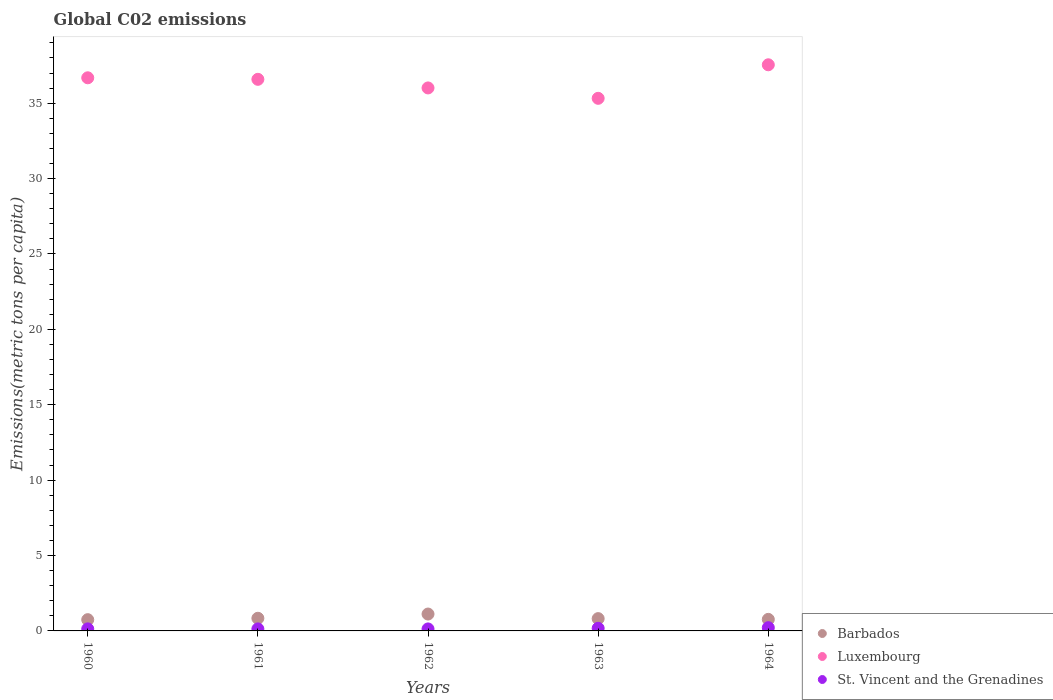Is the number of dotlines equal to the number of legend labels?
Offer a very short reply. Yes. What is the amount of CO2 emitted in in St. Vincent and the Grenadines in 1962?
Provide a succinct answer. 0.13. Across all years, what is the maximum amount of CO2 emitted in in St. Vincent and the Grenadines?
Provide a short and direct response. 0.22. Across all years, what is the minimum amount of CO2 emitted in in Barbados?
Offer a terse response. 0.75. In which year was the amount of CO2 emitted in in Barbados minimum?
Your answer should be compact. 1960. What is the total amount of CO2 emitted in in Luxembourg in the graph?
Your answer should be very brief. 182.15. What is the difference between the amount of CO2 emitted in in Barbados in 1960 and that in 1964?
Your response must be concise. -0.02. What is the difference between the amount of CO2 emitted in in Luxembourg in 1960 and the amount of CO2 emitted in in St. Vincent and the Grenadines in 1961?
Ensure brevity in your answer.  36.55. What is the average amount of CO2 emitted in in Luxembourg per year?
Your response must be concise. 36.43. In the year 1963, what is the difference between the amount of CO2 emitted in in Barbados and amount of CO2 emitted in in St. Vincent and the Grenadines?
Offer a very short reply. 0.64. In how many years, is the amount of CO2 emitted in in Luxembourg greater than 20 metric tons per capita?
Ensure brevity in your answer.  5. What is the ratio of the amount of CO2 emitted in in Barbados in 1962 to that in 1964?
Your response must be concise. 1.46. Is the amount of CO2 emitted in in Luxembourg in 1961 less than that in 1962?
Ensure brevity in your answer.  No. What is the difference between the highest and the second highest amount of CO2 emitted in in Barbados?
Give a very brief answer. 0.28. What is the difference between the highest and the lowest amount of CO2 emitted in in Barbados?
Provide a succinct answer. 0.37. In how many years, is the amount of CO2 emitted in in St. Vincent and the Grenadines greater than the average amount of CO2 emitted in in St. Vincent and the Grenadines taken over all years?
Offer a very short reply. 2. Is it the case that in every year, the sum of the amount of CO2 emitted in in St. Vincent and the Grenadines and amount of CO2 emitted in in Luxembourg  is greater than the amount of CO2 emitted in in Barbados?
Keep it short and to the point. Yes. Is the amount of CO2 emitted in in Barbados strictly greater than the amount of CO2 emitted in in St. Vincent and the Grenadines over the years?
Your response must be concise. Yes. Is the amount of CO2 emitted in in Luxembourg strictly less than the amount of CO2 emitted in in St. Vincent and the Grenadines over the years?
Provide a short and direct response. No. How many dotlines are there?
Give a very brief answer. 3. How many years are there in the graph?
Your answer should be compact. 5. What is the difference between two consecutive major ticks on the Y-axis?
Your response must be concise. 5. Does the graph contain any zero values?
Make the answer very short. No. Where does the legend appear in the graph?
Provide a short and direct response. Bottom right. What is the title of the graph?
Your answer should be very brief. Global C02 emissions. Does "High income: OECD" appear as one of the legend labels in the graph?
Keep it short and to the point. No. What is the label or title of the Y-axis?
Your answer should be very brief. Emissions(metric tons per capita). What is the Emissions(metric tons per capita) of Barbados in 1960?
Keep it short and to the point. 0.75. What is the Emissions(metric tons per capita) in Luxembourg in 1960?
Provide a succinct answer. 36.69. What is the Emissions(metric tons per capita) of St. Vincent and the Grenadines in 1960?
Your response must be concise. 0.14. What is the Emissions(metric tons per capita) of Barbados in 1961?
Make the answer very short. 0.84. What is the Emissions(metric tons per capita) of Luxembourg in 1961?
Your answer should be very brief. 36.58. What is the Emissions(metric tons per capita) in St. Vincent and the Grenadines in 1961?
Give a very brief answer. 0.13. What is the Emissions(metric tons per capita) of Barbados in 1962?
Your answer should be very brief. 1.12. What is the Emissions(metric tons per capita) in Luxembourg in 1962?
Make the answer very short. 36.01. What is the Emissions(metric tons per capita) of St. Vincent and the Grenadines in 1962?
Your response must be concise. 0.13. What is the Emissions(metric tons per capita) of Barbados in 1963?
Keep it short and to the point. 0.82. What is the Emissions(metric tons per capita) in Luxembourg in 1963?
Your answer should be compact. 35.32. What is the Emissions(metric tons per capita) of St. Vincent and the Grenadines in 1963?
Offer a terse response. 0.17. What is the Emissions(metric tons per capita) of Barbados in 1964?
Your answer should be compact. 0.77. What is the Emissions(metric tons per capita) of Luxembourg in 1964?
Give a very brief answer. 37.55. What is the Emissions(metric tons per capita) of St. Vincent and the Grenadines in 1964?
Provide a short and direct response. 0.22. Across all years, what is the maximum Emissions(metric tons per capita) of Barbados?
Keep it short and to the point. 1.12. Across all years, what is the maximum Emissions(metric tons per capita) of Luxembourg?
Offer a very short reply. 37.55. Across all years, what is the maximum Emissions(metric tons per capita) in St. Vincent and the Grenadines?
Offer a terse response. 0.22. Across all years, what is the minimum Emissions(metric tons per capita) in Barbados?
Your response must be concise. 0.75. Across all years, what is the minimum Emissions(metric tons per capita) of Luxembourg?
Provide a short and direct response. 35.32. Across all years, what is the minimum Emissions(metric tons per capita) of St. Vincent and the Grenadines?
Ensure brevity in your answer.  0.13. What is the total Emissions(metric tons per capita) in Barbados in the graph?
Offer a very short reply. 4.29. What is the total Emissions(metric tons per capita) in Luxembourg in the graph?
Keep it short and to the point. 182.15. What is the total Emissions(metric tons per capita) of St. Vincent and the Grenadines in the graph?
Keep it short and to the point. 0.79. What is the difference between the Emissions(metric tons per capita) of Barbados in 1960 and that in 1961?
Your answer should be very brief. -0.09. What is the difference between the Emissions(metric tons per capita) of Luxembourg in 1960 and that in 1961?
Your response must be concise. 0.1. What is the difference between the Emissions(metric tons per capita) of St. Vincent and the Grenadines in 1960 and that in 1961?
Provide a short and direct response. 0. What is the difference between the Emissions(metric tons per capita) of Barbados in 1960 and that in 1962?
Your answer should be compact. -0.37. What is the difference between the Emissions(metric tons per capita) in Luxembourg in 1960 and that in 1962?
Your response must be concise. 0.67. What is the difference between the Emissions(metric tons per capita) of St. Vincent and the Grenadines in 1960 and that in 1962?
Give a very brief answer. 0. What is the difference between the Emissions(metric tons per capita) in Barbados in 1960 and that in 1963?
Your answer should be compact. -0.07. What is the difference between the Emissions(metric tons per capita) in Luxembourg in 1960 and that in 1963?
Your answer should be very brief. 1.36. What is the difference between the Emissions(metric tons per capita) in St. Vincent and the Grenadines in 1960 and that in 1963?
Make the answer very short. -0.04. What is the difference between the Emissions(metric tons per capita) in Barbados in 1960 and that in 1964?
Your answer should be compact. -0.02. What is the difference between the Emissions(metric tons per capita) in Luxembourg in 1960 and that in 1964?
Give a very brief answer. -0.86. What is the difference between the Emissions(metric tons per capita) of St. Vincent and the Grenadines in 1960 and that in 1964?
Offer a very short reply. -0.08. What is the difference between the Emissions(metric tons per capita) in Barbados in 1961 and that in 1962?
Offer a very short reply. -0.28. What is the difference between the Emissions(metric tons per capita) in Luxembourg in 1961 and that in 1962?
Keep it short and to the point. 0.57. What is the difference between the Emissions(metric tons per capita) of St. Vincent and the Grenadines in 1961 and that in 1962?
Provide a short and direct response. 0. What is the difference between the Emissions(metric tons per capita) in Barbados in 1961 and that in 1963?
Offer a terse response. 0.02. What is the difference between the Emissions(metric tons per capita) in Luxembourg in 1961 and that in 1963?
Offer a terse response. 1.26. What is the difference between the Emissions(metric tons per capita) in St. Vincent and the Grenadines in 1961 and that in 1963?
Offer a terse response. -0.04. What is the difference between the Emissions(metric tons per capita) of Barbados in 1961 and that in 1964?
Your answer should be compact. 0.07. What is the difference between the Emissions(metric tons per capita) in Luxembourg in 1961 and that in 1964?
Your answer should be very brief. -0.96. What is the difference between the Emissions(metric tons per capita) in St. Vincent and the Grenadines in 1961 and that in 1964?
Your response must be concise. -0.08. What is the difference between the Emissions(metric tons per capita) in Barbados in 1962 and that in 1963?
Your answer should be compact. 0.3. What is the difference between the Emissions(metric tons per capita) in Luxembourg in 1962 and that in 1963?
Your response must be concise. 0.69. What is the difference between the Emissions(metric tons per capita) in St. Vincent and the Grenadines in 1962 and that in 1963?
Your answer should be compact. -0.04. What is the difference between the Emissions(metric tons per capita) of Barbados in 1962 and that in 1964?
Make the answer very short. 0.35. What is the difference between the Emissions(metric tons per capita) in Luxembourg in 1962 and that in 1964?
Provide a short and direct response. -1.54. What is the difference between the Emissions(metric tons per capita) in St. Vincent and the Grenadines in 1962 and that in 1964?
Give a very brief answer. -0.08. What is the difference between the Emissions(metric tons per capita) of Barbados in 1963 and that in 1964?
Offer a very short reply. 0.05. What is the difference between the Emissions(metric tons per capita) in Luxembourg in 1963 and that in 1964?
Keep it short and to the point. -2.22. What is the difference between the Emissions(metric tons per capita) in St. Vincent and the Grenadines in 1963 and that in 1964?
Your answer should be compact. -0.04. What is the difference between the Emissions(metric tons per capita) in Barbados in 1960 and the Emissions(metric tons per capita) in Luxembourg in 1961?
Your answer should be compact. -35.84. What is the difference between the Emissions(metric tons per capita) of Barbados in 1960 and the Emissions(metric tons per capita) of St. Vincent and the Grenadines in 1961?
Your response must be concise. 0.61. What is the difference between the Emissions(metric tons per capita) in Luxembourg in 1960 and the Emissions(metric tons per capita) in St. Vincent and the Grenadines in 1961?
Ensure brevity in your answer.  36.55. What is the difference between the Emissions(metric tons per capita) in Barbados in 1960 and the Emissions(metric tons per capita) in Luxembourg in 1962?
Provide a succinct answer. -35.27. What is the difference between the Emissions(metric tons per capita) in Barbados in 1960 and the Emissions(metric tons per capita) in St. Vincent and the Grenadines in 1962?
Your answer should be compact. 0.61. What is the difference between the Emissions(metric tons per capita) in Luxembourg in 1960 and the Emissions(metric tons per capita) in St. Vincent and the Grenadines in 1962?
Provide a succinct answer. 36.55. What is the difference between the Emissions(metric tons per capita) of Barbados in 1960 and the Emissions(metric tons per capita) of Luxembourg in 1963?
Your answer should be compact. -34.58. What is the difference between the Emissions(metric tons per capita) of Barbados in 1960 and the Emissions(metric tons per capita) of St. Vincent and the Grenadines in 1963?
Your answer should be very brief. 0.57. What is the difference between the Emissions(metric tons per capita) in Luxembourg in 1960 and the Emissions(metric tons per capita) in St. Vincent and the Grenadines in 1963?
Make the answer very short. 36.51. What is the difference between the Emissions(metric tons per capita) of Barbados in 1960 and the Emissions(metric tons per capita) of Luxembourg in 1964?
Give a very brief answer. -36.8. What is the difference between the Emissions(metric tons per capita) of Barbados in 1960 and the Emissions(metric tons per capita) of St. Vincent and the Grenadines in 1964?
Offer a terse response. 0.53. What is the difference between the Emissions(metric tons per capita) of Luxembourg in 1960 and the Emissions(metric tons per capita) of St. Vincent and the Grenadines in 1964?
Provide a succinct answer. 36.47. What is the difference between the Emissions(metric tons per capita) in Barbados in 1961 and the Emissions(metric tons per capita) in Luxembourg in 1962?
Your response must be concise. -35.17. What is the difference between the Emissions(metric tons per capita) of Barbados in 1961 and the Emissions(metric tons per capita) of St. Vincent and the Grenadines in 1962?
Offer a terse response. 0.71. What is the difference between the Emissions(metric tons per capita) in Luxembourg in 1961 and the Emissions(metric tons per capita) in St. Vincent and the Grenadines in 1962?
Your answer should be compact. 36.45. What is the difference between the Emissions(metric tons per capita) in Barbados in 1961 and the Emissions(metric tons per capita) in Luxembourg in 1963?
Provide a succinct answer. -34.48. What is the difference between the Emissions(metric tons per capita) in Barbados in 1961 and the Emissions(metric tons per capita) in St. Vincent and the Grenadines in 1963?
Make the answer very short. 0.66. What is the difference between the Emissions(metric tons per capita) of Luxembourg in 1961 and the Emissions(metric tons per capita) of St. Vincent and the Grenadines in 1963?
Ensure brevity in your answer.  36.41. What is the difference between the Emissions(metric tons per capita) in Barbados in 1961 and the Emissions(metric tons per capita) in Luxembourg in 1964?
Your response must be concise. -36.71. What is the difference between the Emissions(metric tons per capita) in Barbados in 1961 and the Emissions(metric tons per capita) in St. Vincent and the Grenadines in 1964?
Your response must be concise. 0.62. What is the difference between the Emissions(metric tons per capita) of Luxembourg in 1961 and the Emissions(metric tons per capita) of St. Vincent and the Grenadines in 1964?
Give a very brief answer. 36.37. What is the difference between the Emissions(metric tons per capita) of Barbados in 1962 and the Emissions(metric tons per capita) of Luxembourg in 1963?
Offer a terse response. -34.2. What is the difference between the Emissions(metric tons per capita) of Barbados in 1962 and the Emissions(metric tons per capita) of St. Vincent and the Grenadines in 1963?
Provide a short and direct response. 0.95. What is the difference between the Emissions(metric tons per capita) of Luxembourg in 1962 and the Emissions(metric tons per capita) of St. Vincent and the Grenadines in 1963?
Provide a short and direct response. 35.84. What is the difference between the Emissions(metric tons per capita) in Barbados in 1962 and the Emissions(metric tons per capita) in Luxembourg in 1964?
Your answer should be compact. -36.43. What is the difference between the Emissions(metric tons per capita) of Barbados in 1962 and the Emissions(metric tons per capita) of St. Vincent and the Grenadines in 1964?
Your response must be concise. 0.9. What is the difference between the Emissions(metric tons per capita) of Luxembourg in 1962 and the Emissions(metric tons per capita) of St. Vincent and the Grenadines in 1964?
Offer a very short reply. 35.8. What is the difference between the Emissions(metric tons per capita) in Barbados in 1963 and the Emissions(metric tons per capita) in Luxembourg in 1964?
Provide a short and direct response. -36.73. What is the difference between the Emissions(metric tons per capita) of Barbados in 1963 and the Emissions(metric tons per capita) of St. Vincent and the Grenadines in 1964?
Your answer should be very brief. 0.6. What is the difference between the Emissions(metric tons per capita) of Luxembourg in 1963 and the Emissions(metric tons per capita) of St. Vincent and the Grenadines in 1964?
Offer a terse response. 35.11. What is the average Emissions(metric tons per capita) of Barbados per year?
Ensure brevity in your answer.  0.86. What is the average Emissions(metric tons per capita) in Luxembourg per year?
Offer a terse response. 36.43. What is the average Emissions(metric tons per capita) in St. Vincent and the Grenadines per year?
Offer a very short reply. 0.16. In the year 1960, what is the difference between the Emissions(metric tons per capita) in Barbados and Emissions(metric tons per capita) in Luxembourg?
Keep it short and to the point. -35.94. In the year 1960, what is the difference between the Emissions(metric tons per capita) in Barbados and Emissions(metric tons per capita) in St. Vincent and the Grenadines?
Give a very brief answer. 0.61. In the year 1960, what is the difference between the Emissions(metric tons per capita) in Luxembourg and Emissions(metric tons per capita) in St. Vincent and the Grenadines?
Provide a short and direct response. 36.55. In the year 1961, what is the difference between the Emissions(metric tons per capita) in Barbados and Emissions(metric tons per capita) in Luxembourg?
Offer a terse response. -35.74. In the year 1961, what is the difference between the Emissions(metric tons per capita) of Barbados and Emissions(metric tons per capita) of St. Vincent and the Grenadines?
Your response must be concise. 0.7. In the year 1961, what is the difference between the Emissions(metric tons per capita) of Luxembourg and Emissions(metric tons per capita) of St. Vincent and the Grenadines?
Make the answer very short. 36.45. In the year 1962, what is the difference between the Emissions(metric tons per capita) of Barbados and Emissions(metric tons per capita) of Luxembourg?
Your answer should be very brief. -34.89. In the year 1962, what is the difference between the Emissions(metric tons per capita) of Barbados and Emissions(metric tons per capita) of St. Vincent and the Grenadines?
Offer a terse response. 0.99. In the year 1962, what is the difference between the Emissions(metric tons per capita) in Luxembourg and Emissions(metric tons per capita) in St. Vincent and the Grenadines?
Keep it short and to the point. 35.88. In the year 1963, what is the difference between the Emissions(metric tons per capita) of Barbados and Emissions(metric tons per capita) of Luxembourg?
Give a very brief answer. -34.51. In the year 1963, what is the difference between the Emissions(metric tons per capita) of Barbados and Emissions(metric tons per capita) of St. Vincent and the Grenadines?
Your answer should be very brief. 0.64. In the year 1963, what is the difference between the Emissions(metric tons per capita) of Luxembourg and Emissions(metric tons per capita) of St. Vincent and the Grenadines?
Provide a short and direct response. 35.15. In the year 1964, what is the difference between the Emissions(metric tons per capita) of Barbados and Emissions(metric tons per capita) of Luxembourg?
Make the answer very short. -36.78. In the year 1964, what is the difference between the Emissions(metric tons per capita) of Barbados and Emissions(metric tons per capita) of St. Vincent and the Grenadines?
Offer a terse response. 0.55. In the year 1964, what is the difference between the Emissions(metric tons per capita) of Luxembourg and Emissions(metric tons per capita) of St. Vincent and the Grenadines?
Ensure brevity in your answer.  37.33. What is the ratio of the Emissions(metric tons per capita) in Barbados in 1960 to that in 1961?
Offer a terse response. 0.89. What is the ratio of the Emissions(metric tons per capita) of St. Vincent and the Grenadines in 1960 to that in 1961?
Keep it short and to the point. 1.01. What is the ratio of the Emissions(metric tons per capita) of Barbados in 1960 to that in 1962?
Your response must be concise. 0.67. What is the ratio of the Emissions(metric tons per capita) in Luxembourg in 1960 to that in 1962?
Provide a succinct answer. 1.02. What is the ratio of the Emissions(metric tons per capita) of St. Vincent and the Grenadines in 1960 to that in 1962?
Your answer should be very brief. 1.03. What is the ratio of the Emissions(metric tons per capita) of Barbados in 1960 to that in 1963?
Give a very brief answer. 0.91. What is the ratio of the Emissions(metric tons per capita) of St. Vincent and the Grenadines in 1960 to that in 1963?
Ensure brevity in your answer.  0.78. What is the ratio of the Emissions(metric tons per capita) of Barbados in 1960 to that in 1964?
Provide a short and direct response. 0.97. What is the ratio of the Emissions(metric tons per capita) of St. Vincent and the Grenadines in 1960 to that in 1964?
Provide a short and direct response. 0.63. What is the ratio of the Emissions(metric tons per capita) in Barbados in 1961 to that in 1962?
Your response must be concise. 0.75. What is the ratio of the Emissions(metric tons per capita) of Luxembourg in 1961 to that in 1962?
Ensure brevity in your answer.  1.02. What is the ratio of the Emissions(metric tons per capita) of St. Vincent and the Grenadines in 1961 to that in 1962?
Your response must be concise. 1.01. What is the ratio of the Emissions(metric tons per capita) in Barbados in 1961 to that in 1963?
Give a very brief answer. 1.03. What is the ratio of the Emissions(metric tons per capita) of Luxembourg in 1961 to that in 1963?
Your answer should be very brief. 1.04. What is the ratio of the Emissions(metric tons per capita) of St. Vincent and the Grenadines in 1961 to that in 1963?
Your answer should be very brief. 0.77. What is the ratio of the Emissions(metric tons per capita) of Barbados in 1961 to that in 1964?
Provide a succinct answer. 1.09. What is the ratio of the Emissions(metric tons per capita) in Luxembourg in 1961 to that in 1964?
Provide a succinct answer. 0.97. What is the ratio of the Emissions(metric tons per capita) of St. Vincent and the Grenadines in 1961 to that in 1964?
Ensure brevity in your answer.  0.62. What is the ratio of the Emissions(metric tons per capita) of Barbados in 1962 to that in 1963?
Provide a short and direct response. 1.37. What is the ratio of the Emissions(metric tons per capita) of Luxembourg in 1962 to that in 1963?
Provide a succinct answer. 1.02. What is the ratio of the Emissions(metric tons per capita) of St. Vincent and the Grenadines in 1962 to that in 1963?
Give a very brief answer. 0.76. What is the ratio of the Emissions(metric tons per capita) in Barbados in 1962 to that in 1964?
Your response must be concise. 1.46. What is the ratio of the Emissions(metric tons per capita) in Luxembourg in 1962 to that in 1964?
Your answer should be very brief. 0.96. What is the ratio of the Emissions(metric tons per capita) of St. Vincent and the Grenadines in 1962 to that in 1964?
Your answer should be very brief. 0.61. What is the ratio of the Emissions(metric tons per capita) in Barbados in 1963 to that in 1964?
Offer a very short reply. 1.07. What is the ratio of the Emissions(metric tons per capita) of Luxembourg in 1963 to that in 1964?
Offer a very short reply. 0.94. What is the ratio of the Emissions(metric tons per capita) in St. Vincent and the Grenadines in 1963 to that in 1964?
Provide a succinct answer. 0.81. What is the difference between the highest and the second highest Emissions(metric tons per capita) of Barbados?
Ensure brevity in your answer.  0.28. What is the difference between the highest and the second highest Emissions(metric tons per capita) of Luxembourg?
Keep it short and to the point. 0.86. What is the difference between the highest and the second highest Emissions(metric tons per capita) of St. Vincent and the Grenadines?
Your answer should be very brief. 0.04. What is the difference between the highest and the lowest Emissions(metric tons per capita) in Barbados?
Your response must be concise. 0.37. What is the difference between the highest and the lowest Emissions(metric tons per capita) in Luxembourg?
Give a very brief answer. 2.22. What is the difference between the highest and the lowest Emissions(metric tons per capita) of St. Vincent and the Grenadines?
Your answer should be compact. 0.08. 